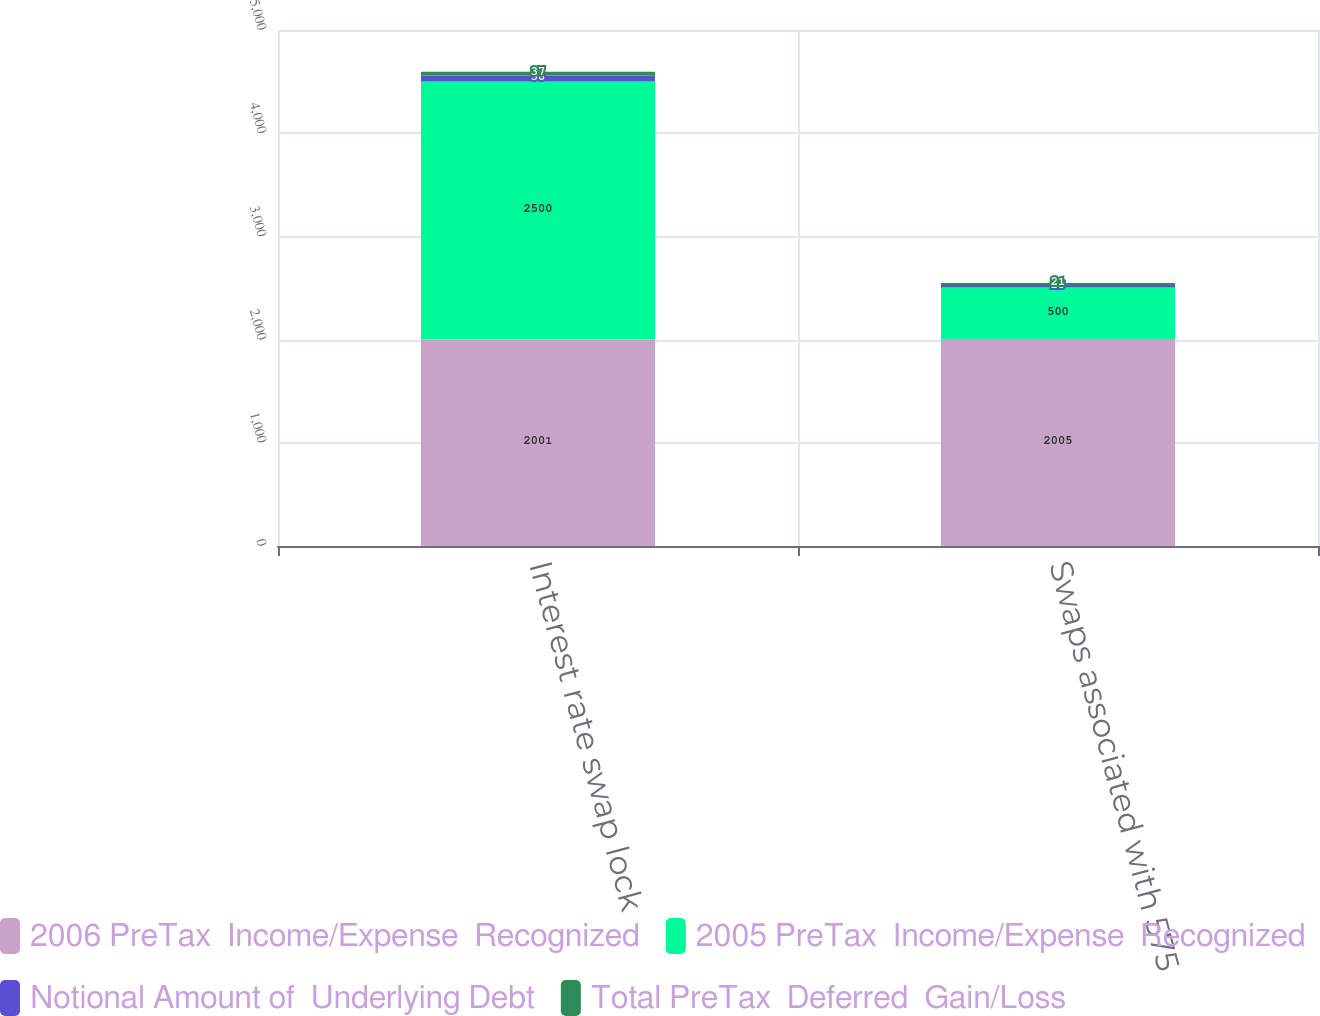<chart> <loc_0><loc_0><loc_500><loc_500><stacked_bar_chart><ecel><fcel>Interest rate swap lock<fcel>Swaps associated with 575<nl><fcel>2006 PreTax  Income/Expense  Recognized<fcel>2001<fcel>2005<nl><fcel>2005 PreTax  Income/Expense  Recognized<fcel>2500<fcel>500<nl><fcel>Notional Amount of  Underlying Debt<fcel>58<fcel>23<nl><fcel>Total PreTax  Deferred  Gain/Loss<fcel>37<fcel>21<nl></chart> 